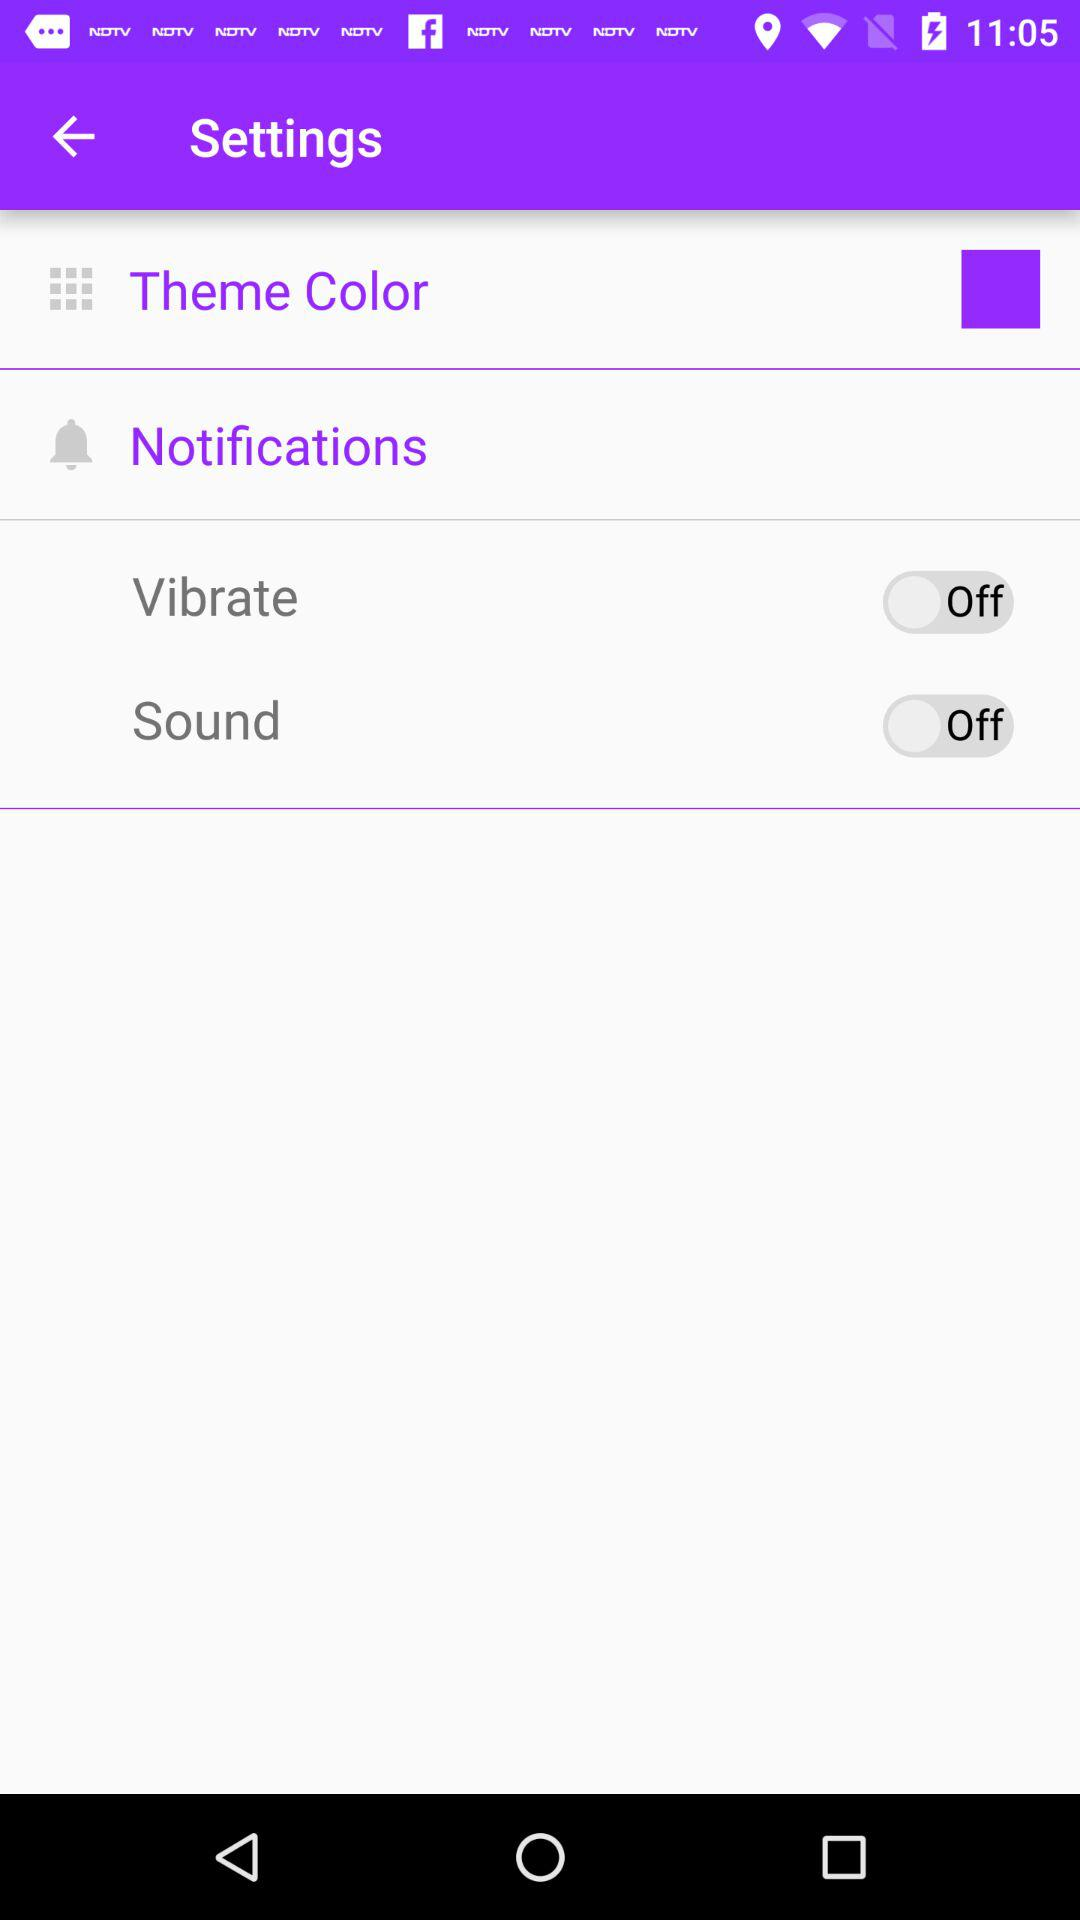How many items in the Settings menu have a switch associated with them?
Answer the question using a single word or phrase. 2 